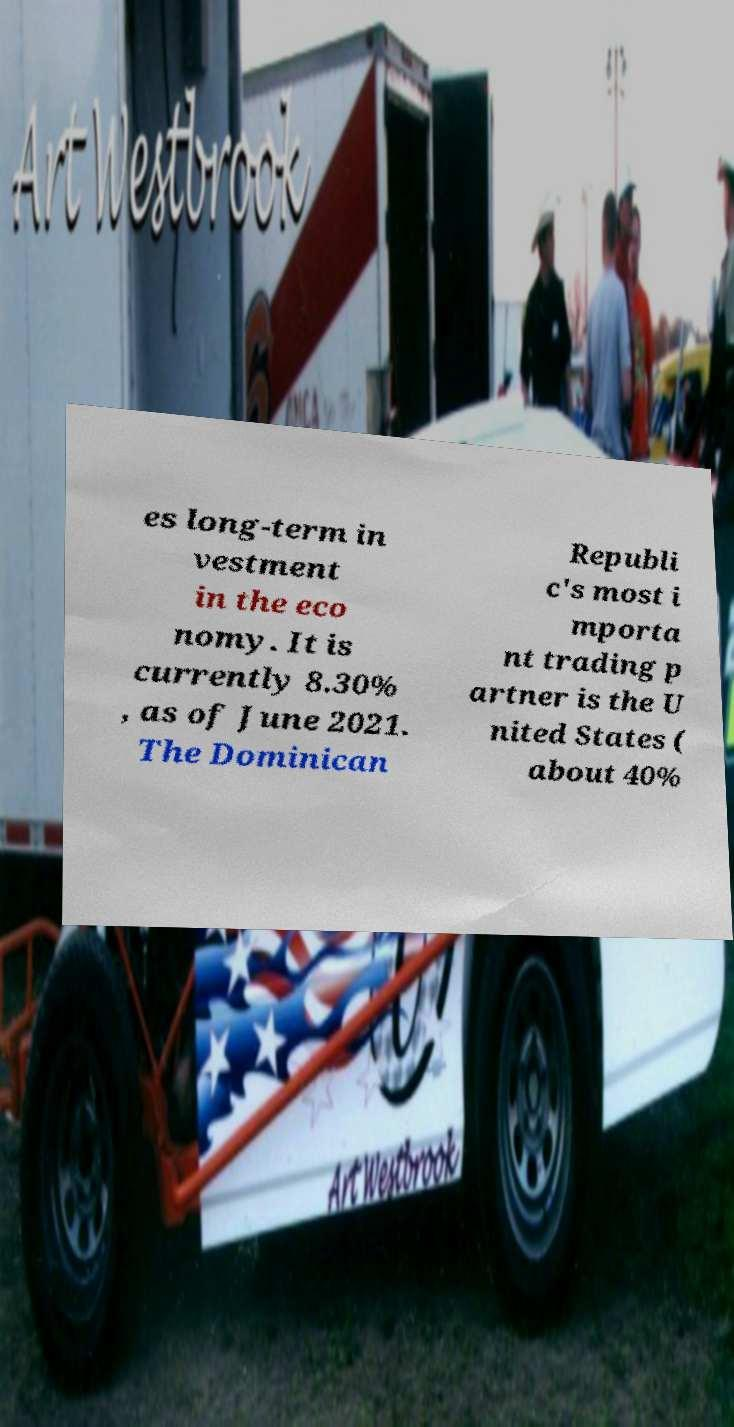There's text embedded in this image that I need extracted. Can you transcribe it verbatim? es long-term in vestment in the eco nomy. It is currently 8.30% , as of June 2021. The Dominican Republi c's most i mporta nt trading p artner is the U nited States ( about 40% 